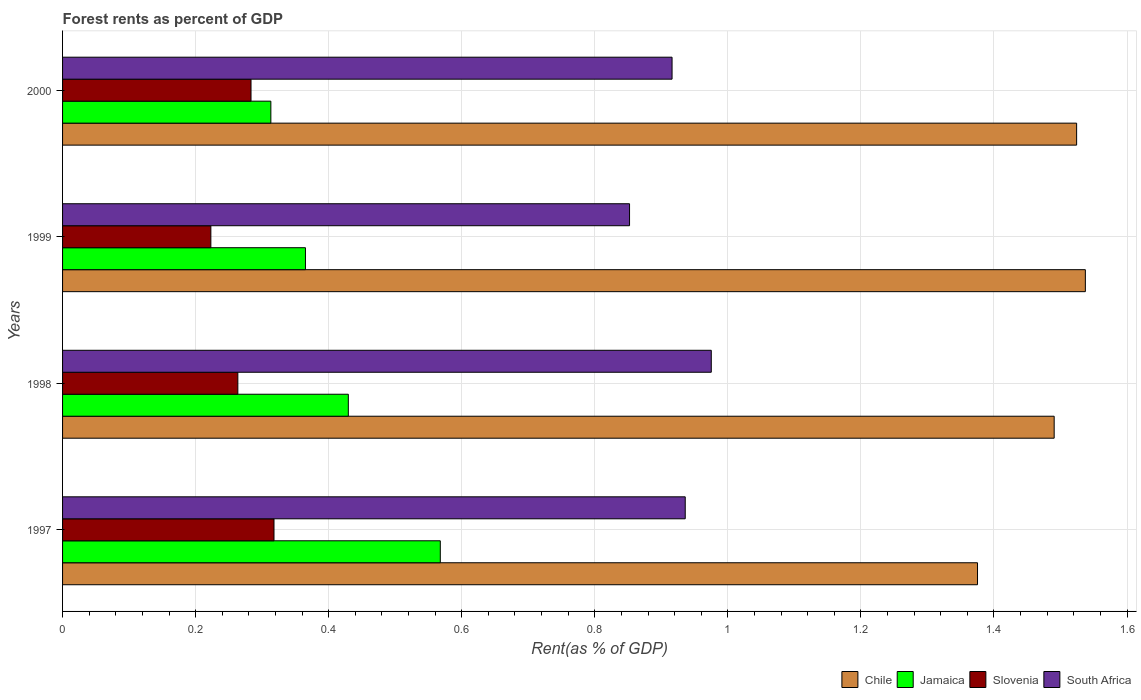How many bars are there on the 2nd tick from the top?
Ensure brevity in your answer.  4. What is the forest rent in South Africa in 2000?
Your answer should be very brief. 0.92. Across all years, what is the maximum forest rent in Jamaica?
Offer a terse response. 0.57. Across all years, what is the minimum forest rent in Slovenia?
Give a very brief answer. 0.22. In which year was the forest rent in Chile minimum?
Your answer should be compact. 1997. What is the total forest rent in Jamaica in the graph?
Keep it short and to the point. 1.68. What is the difference between the forest rent in Chile in 1997 and that in 1998?
Give a very brief answer. -0.12. What is the difference between the forest rent in Jamaica in 1997 and the forest rent in Slovenia in 1999?
Ensure brevity in your answer.  0.34. What is the average forest rent in Slovenia per year?
Offer a terse response. 0.27. In the year 1997, what is the difference between the forest rent in South Africa and forest rent in Slovenia?
Offer a terse response. 0.62. What is the ratio of the forest rent in Slovenia in 1997 to that in 2000?
Ensure brevity in your answer.  1.12. Is the difference between the forest rent in South Africa in 1997 and 1999 greater than the difference between the forest rent in Slovenia in 1997 and 1999?
Give a very brief answer. No. What is the difference between the highest and the second highest forest rent in Jamaica?
Offer a very short reply. 0.14. What is the difference between the highest and the lowest forest rent in Chile?
Keep it short and to the point. 0.16. Is the sum of the forest rent in Slovenia in 1998 and 1999 greater than the maximum forest rent in Chile across all years?
Provide a short and direct response. No. What does the 4th bar from the bottom in 1998 represents?
Make the answer very short. South Africa. How many bars are there?
Give a very brief answer. 16. Are all the bars in the graph horizontal?
Keep it short and to the point. Yes. What is the difference between two consecutive major ticks on the X-axis?
Keep it short and to the point. 0.2. Does the graph contain any zero values?
Ensure brevity in your answer.  No. Does the graph contain grids?
Give a very brief answer. Yes. What is the title of the graph?
Offer a very short reply. Forest rents as percent of GDP. What is the label or title of the X-axis?
Give a very brief answer. Rent(as % of GDP). What is the Rent(as % of GDP) of Chile in 1997?
Offer a very short reply. 1.38. What is the Rent(as % of GDP) in Jamaica in 1997?
Provide a short and direct response. 0.57. What is the Rent(as % of GDP) in Slovenia in 1997?
Keep it short and to the point. 0.32. What is the Rent(as % of GDP) in South Africa in 1997?
Provide a succinct answer. 0.94. What is the Rent(as % of GDP) in Chile in 1998?
Ensure brevity in your answer.  1.49. What is the Rent(as % of GDP) of Jamaica in 1998?
Your answer should be very brief. 0.43. What is the Rent(as % of GDP) in Slovenia in 1998?
Your answer should be compact. 0.26. What is the Rent(as % of GDP) in South Africa in 1998?
Keep it short and to the point. 0.98. What is the Rent(as % of GDP) of Chile in 1999?
Make the answer very short. 1.54. What is the Rent(as % of GDP) in Jamaica in 1999?
Make the answer very short. 0.37. What is the Rent(as % of GDP) in Slovenia in 1999?
Keep it short and to the point. 0.22. What is the Rent(as % of GDP) in South Africa in 1999?
Offer a terse response. 0.85. What is the Rent(as % of GDP) in Chile in 2000?
Your answer should be compact. 1.52. What is the Rent(as % of GDP) in Jamaica in 2000?
Your answer should be very brief. 0.31. What is the Rent(as % of GDP) in Slovenia in 2000?
Your answer should be very brief. 0.28. What is the Rent(as % of GDP) of South Africa in 2000?
Your answer should be very brief. 0.92. Across all years, what is the maximum Rent(as % of GDP) of Chile?
Provide a short and direct response. 1.54. Across all years, what is the maximum Rent(as % of GDP) in Jamaica?
Provide a short and direct response. 0.57. Across all years, what is the maximum Rent(as % of GDP) of Slovenia?
Offer a terse response. 0.32. Across all years, what is the maximum Rent(as % of GDP) in South Africa?
Offer a very short reply. 0.98. Across all years, what is the minimum Rent(as % of GDP) of Chile?
Provide a short and direct response. 1.38. Across all years, what is the minimum Rent(as % of GDP) in Jamaica?
Give a very brief answer. 0.31. Across all years, what is the minimum Rent(as % of GDP) in Slovenia?
Provide a succinct answer. 0.22. Across all years, what is the minimum Rent(as % of GDP) of South Africa?
Provide a succinct answer. 0.85. What is the total Rent(as % of GDP) of Chile in the graph?
Offer a terse response. 5.93. What is the total Rent(as % of GDP) of Jamaica in the graph?
Ensure brevity in your answer.  1.68. What is the total Rent(as % of GDP) of Slovenia in the graph?
Your answer should be very brief. 1.09. What is the total Rent(as % of GDP) in South Africa in the graph?
Make the answer very short. 3.68. What is the difference between the Rent(as % of GDP) of Chile in 1997 and that in 1998?
Offer a terse response. -0.12. What is the difference between the Rent(as % of GDP) of Jamaica in 1997 and that in 1998?
Keep it short and to the point. 0.14. What is the difference between the Rent(as % of GDP) in Slovenia in 1997 and that in 1998?
Provide a short and direct response. 0.05. What is the difference between the Rent(as % of GDP) of South Africa in 1997 and that in 1998?
Your answer should be very brief. -0.04. What is the difference between the Rent(as % of GDP) of Chile in 1997 and that in 1999?
Your answer should be very brief. -0.16. What is the difference between the Rent(as % of GDP) of Jamaica in 1997 and that in 1999?
Your response must be concise. 0.2. What is the difference between the Rent(as % of GDP) of Slovenia in 1997 and that in 1999?
Your answer should be compact. 0.09. What is the difference between the Rent(as % of GDP) in South Africa in 1997 and that in 1999?
Ensure brevity in your answer.  0.08. What is the difference between the Rent(as % of GDP) in Chile in 1997 and that in 2000?
Make the answer very short. -0.15. What is the difference between the Rent(as % of GDP) in Jamaica in 1997 and that in 2000?
Make the answer very short. 0.25. What is the difference between the Rent(as % of GDP) in Slovenia in 1997 and that in 2000?
Ensure brevity in your answer.  0.03. What is the difference between the Rent(as % of GDP) in South Africa in 1997 and that in 2000?
Your answer should be very brief. 0.02. What is the difference between the Rent(as % of GDP) of Chile in 1998 and that in 1999?
Your response must be concise. -0.05. What is the difference between the Rent(as % of GDP) of Jamaica in 1998 and that in 1999?
Your answer should be compact. 0.06. What is the difference between the Rent(as % of GDP) of Slovenia in 1998 and that in 1999?
Your answer should be very brief. 0.04. What is the difference between the Rent(as % of GDP) of South Africa in 1998 and that in 1999?
Offer a terse response. 0.12. What is the difference between the Rent(as % of GDP) of Chile in 1998 and that in 2000?
Make the answer very short. -0.03. What is the difference between the Rent(as % of GDP) of Jamaica in 1998 and that in 2000?
Keep it short and to the point. 0.12. What is the difference between the Rent(as % of GDP) of Slovenia in 1998 and that in 2000?
Give a very brief answer. -0.02. What is the difference between the Rent(as % of GDP) of South Africa in 1998 and that in 2000?
Provide a short and direct response. 0.06. What is the difference between the Rent(as % of GDP) of Chile in 1999 and that in 2000?
Your response must be concise. 0.01. What is the difference between the Rent(as % of GDP) in Jamaica in 1999 and that in 2000?
Your response must be concise. 0.05. What is the difference between the Rent(as % of GDP) of Slovenia in 1999 and that in 2000?
Your answer should be very brief. -0.06. What is the difference between the Rent(as % of GDP) of South Africa in 1999 and that in 2000?
Offer a terse response. -0.06. What is the difference between the Rent(as % of GDP) of Chile in 1997 and the Rent(as % of GDP) of Jamaica in 1998?
Provide a succinct answer. 0.95. What is the difference between the Rent(as % of GDP) in Chile in 1997 and the Rent(as % of GDP) in Slovenia in 1998?
Provide a short and direct response. 1.11. What is the difference between the Rent(as % of GDP) of Chile in 1997 and the Rent(as % of GDP) of South Africa in 1998?
Provide a succinct answer. 0.4. What is the difference between the Rent(as % of GDP) of Jamaica in 1997 and the Rent(as % of GDP) of Slovenia in 1998?
Your answer should be compact. 0.3. What is the difference between the Rent(as % of GDP) of Jamaica in 1997 and the Rent(as % of GDP) of South Africa in 1998?
Keep it short and to the point. -0.41. What is the difference between the Rent(as % of GDP) in Slovenia in 1997 and the Rent(as % of GDP) in South Africa in 1998?
Give a very brief answer. -0.66. What is the difference between the Rent(as % of GDP) in Chile in 1997 and the Rent(as % of GDP) in Jamaica in 1999?
Your answer should be very brief. 1.01. What is the difference between the Rent(as % of GDP) of Chile in 1997 and the Rent(as % of GDP) of Slovenia in 1999?
Provide a succinct answer. 1.15. What is the difference between the Rent(as % of GDP) of Chile in 1997 and the Rent(as % of GDP) of South Africa in 1999?
Your response must be concise. 0.52. What is the difference between the Rent(as % of GDP) of Jamaica in 1997 and the Rent(as % of GDP) of Slovenia in 1999?
Ensure brevity in your answer.  0.34. What is the difference between the Rent(as % of GDP) of Jamaica in 1997 and the Rent(as % of GDP) of South Africa in 1999?
Your answer should be compact. -0.28. What is the difference between the Rent(as % of GDP) in Slovenia in 1997 and the Rent(as % of GDP) in South Africa in 1999?
Your answer should be compact. -0.53. What is the difference between the Rent(as % of GDP) in Chile in 1997 and the Rent(as % of GDP) in Jamaica in 2000?
Provide a succinct answer. 1.06. What is the difference between the Rent(as % of GDP) in Chile in 1997 and the Rent(as % of GDP) in Slovenia in 2000?
Make the answer very short. 1.09. What is the difference between the Rent(as % of GDP) in Chile in 1997 and the Rent(as % of GDP) in South Africa in 2000?
Make the answer very short. 0.46. What is the difference between the Rent(as % of GDP) of Jamaica in 1997 and the Rent(as % of GDP) of Slovenia in 2000?
Offer a terse response. 0.28. What is the difference between the Rent(as % of GDP) in Jamaica in 1997 and the Rent(as % of GDP) in South Africa in 2000?
Provide a short and direct response. -0.35. What is the difference between the Rent(as % of GDP) of Slovenia in 1997 and the Rent(as % of GDP) of South Africa in 2000?
Your answer should be compact. -0.6. What is the difference between the Rent(as % of GDP) of Chile in 1998 and the Rent(as % of GDP) of Jamaica in 1999?
Your response must be concise. 1.13. What is the difference between the Rent(as % of GDP) in Chile in 1998 and the Rent(as % of GDP) in Slovenia in 1999?
Keep it short and to the point. 1.27. What is the difference between the Rent(as % of GDP) of Chile in 1998 and the Rent(as % of GDP) of South Africa in 1999?
Give a very brief answer. 0.64. What is the difference between the Rent(as % of GDP) of Jamaica in 1998 and the Rent(as % of GDP) of Slovenia in 1999?
Your response must be concise. 0.21. What is the difference between the Rent(as % of GDP) of Jamaica in 1998 and the Rent(as % of GDP) of South Africa in 1999?
Give a very brief answer. -0.42. What is the difference between the Rent(as % of GDP) in Slovenia in 1998 and the Rent(as % of GDP) in South Africa in 1999?
Keep it short and to the point. -0.59. What is the difference between the Rent(as % of GDP) in Chile in 1998 and the Rent(as % of GDP) in Jamaica in 2000?
Make the answer very short. 1.18. What is the difference between the Rent(as % of GDP) of Chile in 1998 and the Rent(as % of GDP) of Slovenia in 2000?
Offer a very short reply. 1.21. What is the difference between the Rent(as % of GDP) in Chile in 1998 and the Rent(as % of GDP) in South Africa in 2000?
Give a very brief answer. 0.57. What is the difference between the Rent(as % of GDP) of Jamaica in 1998 and the Rent(as % of GDP) of Slovenia in 2000?
Your answer should be compact. 0.15. What is the difference between the Rent(as % of GDP) in Jamaica in 1998 and the Rent(as % of GDP) in South Africa in 2000?
Give a very brief answer. -0.49. What is the difference between the Rent(as % of GDP) in Slovenia in 1998 and the Rent(as % of GDP) in South Africa in 2000?
Your response must be concise. -0.65. What is the difference between the Rent(as % of GDP) in Chile in 1999 and the Rent(as % of GDP) in Jamaica in 2000?
Offer a very short reply. 1.22. What is the difference between the Rent(as % of GDP) in Chile in 1999 and the Rent(as % of GDP) in Slovenia in 2000?
Provide a succinct answer. 1.25. What is the difference between the Rent(as % of GDP) in Chile in 1999 and the Rent(as % of GDP) in South Africa in 2000?
Provide a succinct answer. 0.62. What is the difference between the Rent(as % of GDP) in Jamaica in 1999 and the Rent(as % of GDP) in Slovenia in 2000?
Ensure brevity in your answer.  0.08. What is the difference between the Rent(as % of GDP) in Jamaica in 1999 and the Rent(as % of GDP) in South Africa in 2000?
Offer a terse response. -0.55. What is the difference between the Rent(as % of GDP) of Slovenia in 1999 and the Rent(as % of GDP) of South Africa in 2000?
Make the answer very short. -0.69. What is the average Rent(as % of GDP) of Chile per year?
Provide a short and direct response. 1.48. What is the average Rent(as % of GDP) in Jamaica per year?
Your answer should be compact. 0.42. What is the average Rent(as % of GDP) in Slovenia per year?
Your answer should be very brief. 0.27. What is the average Rent(as % of GDP) in South Africa per year?
Provide a short and direct response. 0.92. In the year 1997, what is the difference between the Rent(as % of GDP) of Chile and Rent(as % of GDP) of Jamaica?
Keep it short and to the point. 0.81. In the year 1997, what is the difference between the Rent(as % of GDP) of Chile and Rent(as % of GDP) of Slovenia?
Your answer should be compact. 1.06. In the year 1997, what is the difference between the Rent(as % of GDP) of Chile and Rent(as % of GDP) of South Africa?
Offer a terse response. 0.44. In the year 1997, what is the difference between the Rent(as % of GDP) of Jamaica and Rent(as % of GDP) of Slovenia?
Provide a succinct answer. 0.25. In the year 1997, what is the difference between the Rent(as % of GDP) in Jamaica and Rent(as % of GDP) in South Africa?
Offer a very short reply. -0.37. In the year 1997, what is the difference between the Rent(as % of GDP) of Slovenia and Rent(as % of GDP) of South Africa?
Your answer should be compact. -0.62. In the year 1998, what is the difference between the Rent(as % of GDP) of Chile and Rent(as % of GDP) of Jamaica?
Your answer should be compact. 1.06. In the year 1998, what is the difference between the Rent(as % of GDP) of Chile and Rent(as % of GDP) of Slovenia?
Give a very brief answer. 1.23. In the year 1998, what is the difference between the Rent(as % of GDP) in Chile and Rent(as % of GDP) in South Africa?
Keep it short and to the point. 0.52. In the year 1998, what is the difference between the Rent(as % of GDP) of Jamaica and Rent(as % of GDP) of Slovenia?
Your answer should be compact. 0.17. In the year 1998, what is the difference between the Rent(as % of GDP) in Jamaica and Rent(as % of GDP) in South Africa?
Your answer should be compact. -0.55. In the year 1998, what is the difference between the Rent(as % of GDP) in Slovenia and Rent(as % of GDP) in South Africa?
Your answer should be very brief. -0.71. In the year 1999, what is the difference between the Rent(as % of GDP) in Chile and Rent(as % of GDP) in Jamaica?
Provide a succinct answer. 1.17. In the year 1999, what is the difference between the Rent(as % of GDP) in Chile and Rent(as % of GDP) in Slovenia?
Your answer should be very brief. 1.31. In the year 1999, what is the difference between the Rent(as % of GDP) of Chile and Rent(as % of GDP) of South Africa?
Offer a very short reply. 0.69. In the year 1999, what is the difference between the Rent(as % of GDP) of Jamaica and Rent(as % of GDP) of Slovenia?
Offer a terse response. 0.14. In the year 1999, what is the difference between the Rent(as % of GDP) of Jamaica and Rent(as % of GDP) of South Africa?
Offer a very short reply. -0.49. In the year 1999, what is the difference between the Rent(as % of GDP) of Slovenia and Rent(as % of GDP) of South Africa?
Your answer should be very brief. -0.63. In the year 2000, what is the difference between the Rent(as % of GDP) of Chile and Rent(as % of GDP) of Jamaica?
Offer a terse response. 1.21. In the year 2000, what is the difference between the Rent(as % of GDP) in Chile and Rent(as % of GDP) in Slovenia?
Keep it short and to the point. 1.24. In the year 2000, what is the difference between the Rent(as % of GDP) of Chile and Rent(as % of GDP) of South Africa?
Provide a succinct answer. 0.61. In the year 2000, what is the difference between the Rent(as % of GDP) in Jamaica and Rent(as % of GDP) in Slovenia?
Your answer should be compact. 0.03. In the year 2000, what is the difference between the Rent(as % of GDP) of Jamaica and Rent(as % of GDP) of South Africa?
Make the answer very short. -0.6. In the year 2000, what is the difference between the Rent(as % of GDP) in Slovenia and Rent(as % of GDP) in South Africa?
Your answer should be very brief. -0.63. What is the ratio of the Rent(as % of GDP) of Chile in 1997 to that in 1998?
Give a very brief answer. 0.92. What is the ratio of the Rent(as % of GDP) in Jamaica in 1997 to that in 1998?
Provide a succinct answer. 1.32. What is the ratio of the Rent(as % of GDP) in Slovenia in 1997 to that in 1998?
Offer a very short reply. 1.21. What is the ratio of the Rent(as % of GDP) of South Africa in 1997 to that in 1998?
Keep it short and to the point. 0.96. What is the ratio of the Rent(as % of GDP) of Chile in 1997 to that in 1999?
Ensure brevity in your answer.  0.89. What is the ratio of the Rent(as % of GDP) in Jamaica in 1997 to that in 1999?
Your answer should be very brief. 1.56. What is the ratio of the Rent(as % of GDP) in Slovenia in 1997 to that in 1999?
Your response must be concise. 1.43. What is the ratio of the Rent(as % of GDP) of South Africa in 1997 to that in 1999?
Your answer should be very brief. 1.1. What is the ratio of the Rent(as % of GDP) in Chile in 1997 to that in 2000?
Provide a succinct answer. 0.9. What is the ratio of the Rent(as % of GDP) in Jamaica in 1997 to that in 2000?
Your response must be concise. 1.81. What is the ratio of the Rent(as % of GDP) in Slovenia in 1997 to that in 2000?
Give a very brief answer. 1.12. What is the ratio of the Rent(as % of GDP) in South Africa in 1997 to that in 2000?
Keep it short and to the point. 1.02. What is the ratio of the Rent(as % of GDP) of Chile in 1998 to that in 1999?
Offer a very short reply. 0.97. What is the ratio of the Rent(as % of GDP) of Jamaica in 1998 to that in 1999?
Ensure brevity in your answer.  1.18. What is the ratio of the Rent(as % of GDP) in Slovenia in 1998 to that in 1999?
Your answer should be compact. 1.18. What is the ratio of the Rent(as % of GDP) of South Africa in 1998 to that in 1999?
Your answer should be very brief. 1.14. What is the ratio of the Rent(as % of GDP) of Chile in 1998 to that in 2000?
Keep it short and to the point. 0.98. What is the ratio of the Rent(as % of GDP) of Jamaica in 1998 to that in 2000?
Provide a short and direct response. 1.37. What is the ratio of the Rent(as % of GDP) in Slovenia in 1998 to that in 2000?
Provide a succinct answer. 0.93. What is the ratio of the Rent(as % of GDP) in South Africa in 1998 to that in 2000?
Your answer should be compact. 1.06. What is the ratio of the Rent(as % of GDP) of Chile in 1999 to that in 2000?
Your answer should be compact. 1.01. What is the ratio of the Rent(as % of GDP) of Jamaica in 1999 to that in 2000?
Ensure brevity in your answer.  1.17. What is the ratio of the Rent(as % of GDP) of Slovenia in 1999 to that in 2000?
Offer a terse response. 0.79. What is the ratio of the Rent(as % of GDP) of South Africa in 1999 to that in 2000?
Provide a short and direct response. 0.93. What is the difference between the highest and the second highest Rent(as % of GDP) in Chile?
Offer a terse response. 0.01. What is the difference between the highest and the second highest Rent(as % of GDP) in Jamaica?
Give a very brief answer. 0.14. What is the difference between the highest and the second highest Rent(as % of GDP) of Slovenia?
Provide a succinct answer. 0.03. What is the difference between the highest and the second highest Rent(as % of GDP) of South Africa?
Offer a terse response. 0.04. What is the difference between the highest and the lowest Rent(as % of GDP) in Chile?
Give a very brief answer. 0.16. What is the difference between the highest and the lowest Rent(as % of GDP) of Jamaica?
Provide a succinct answer. 0.25. What is the difference between the highest and the lowest Rent(as % of GDP) of Slovenia?
Give a very brief answer. 0.09. What is the difference between the highest and the lowest Rent(as % of GDP) of South Africa?
Provide a short and direct response. 0.12. 